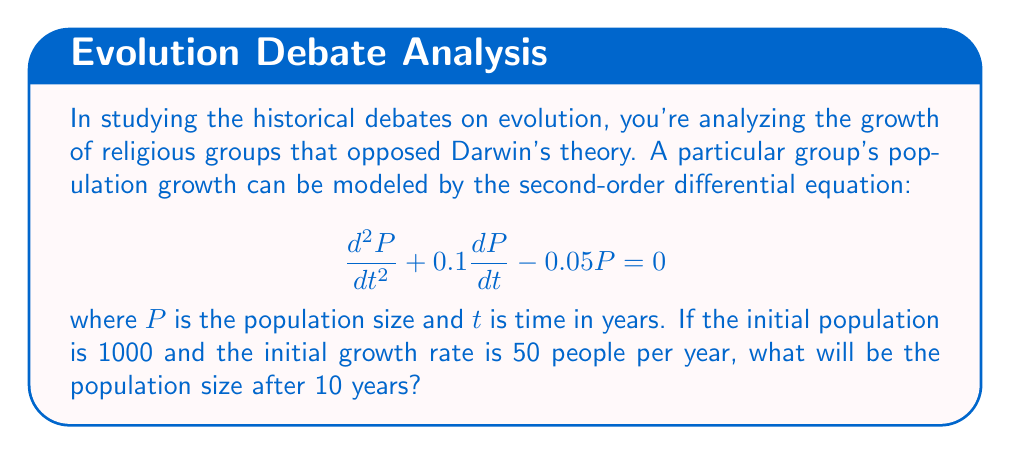Provide a solution to this math problem. To solve this problem, we'll follow these steps:

1) The general solution for this second-order linear differential equation is:
   $$P(t) = C_1e^{r_1t} + C_2e^{r_2t}$$
   where $r_1$ and $r_2$ are roots of the characteristic equation.

2) The characteristic equation is:
   $$r^2 + 0.1r - 0.05 = 0$$

3) Solving this quadratic equation:
   $$r = \frac{-0.1 \pm \sqrt{0.1^2 + 4(0.05)}}{2} = \frac{-0.1 \pm \sqrt{0.21}}{2}$$
   $$r_1 \approx 0.1789 \text{ and } r_2 \approx -0.2789$$

4) Therefore, the general solution is:
   $$P(t) = C_1e^{0.1789t} + C_2e^{-0.2789t}$$

5) Using the initial conditions:
   At $t=0$, $P(0) = 1000$, so:
   $$1000 = C_1 + C_2$$

   Also, $\frac{dP}{dt}(0) = 50$, so:
   $$50 = 0.1789C_1 - 0.2789C_2$$

6) Solving these equations:
   $$C_1 \approx 723.94 \text{ and } C_2 \approx 276.06$$

7) The particular solution is:
   $$P(t) = 723.94e^{0.1789t} + 276.06e^{-0.2789t}$$

8) To find the population after 10 years, calculate $P(10)$:
   $$P(10) = 723.94e^{0.1789(10)} + 276.06e^{-0.2789(10)} \approx 2026.7$$
Answer: 2027 people (rounded to the nearest whole number) 